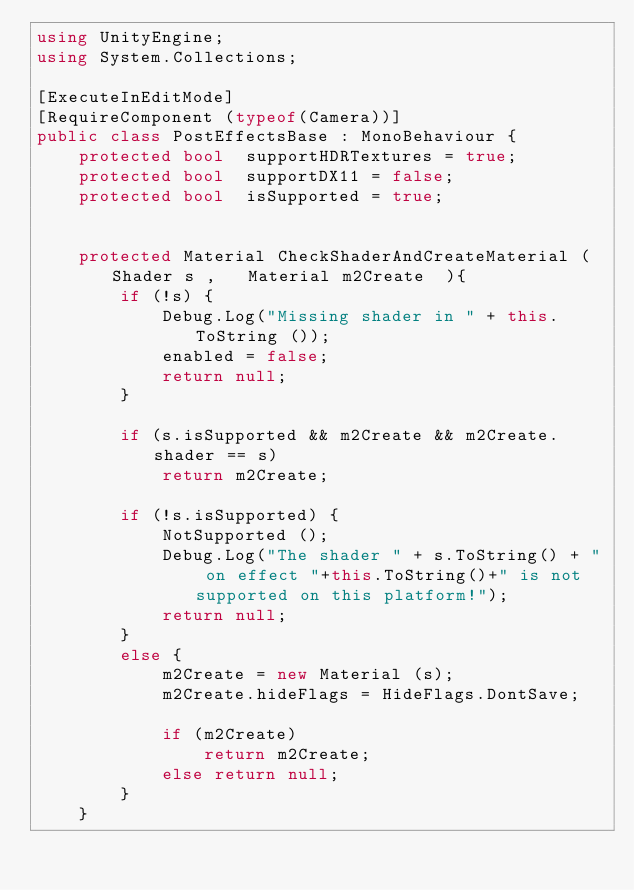<code> <loc_0><loc_0><loc_500><loc_500><_C#_>using UnityEngine;
using System.Collections;

[ExecuteInEditMode]
[RequireComponent (typeof(Camera))]
public class PostEffectsBase : MonoBehaviour {	
	protected bool  supportHDRTextures = true;
	protected bool  supportDX11 = false;
	protected bool  isSupported = true;


    protected Material CheckShaderAndCreateMaterial ( Shader s ,   Material m2Create  ){
		if (!s) { 
			Debug.Log("Missing shader in " + this.ToString ());
			enabled = false;
			return null;
		}
			
		if (s.isSupported && m2Create && m2Create.shader == s) 
			return m2Create;
		
		if (!s.isSupported) {
			NotSupported ();
			Debug.Log("The shader " + s.ToString() + " on effect "+this.ToString()+" is not supported on this platform!");
			return null;
		}
		else {
			m2Create = new Material (s);	
			m2Create.hideFlags = HideFlags.DontSave;		
			if (m2Create) 
				return m2Create;
			else return null;
		}
	}

</code> 